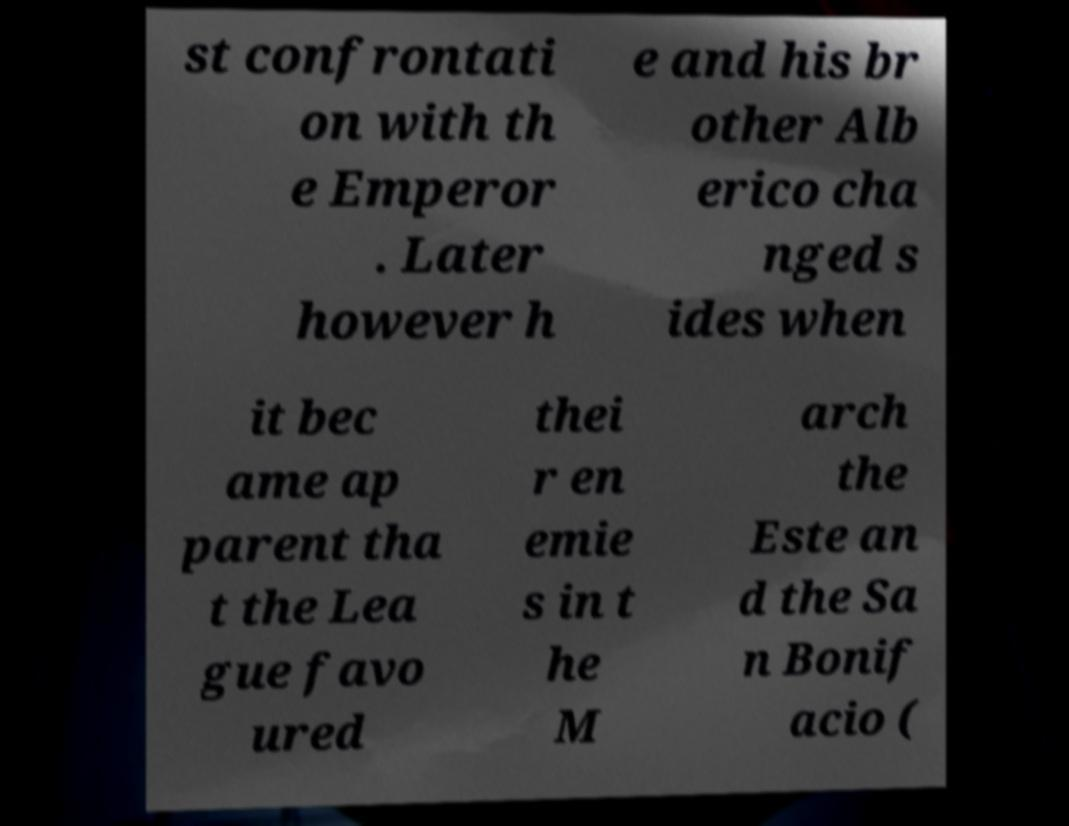There's text embedded in this image that I need extracted. Can you transcribe it verbatim? st confrontati on with th e Emperor . Later however h e and his br other Alb erico cha nged s ides when it bec ame ap parent tha t the Lea gue favo ured thei r en emie s in t he M arch the Este an d the Sa n Bonif acio ( 